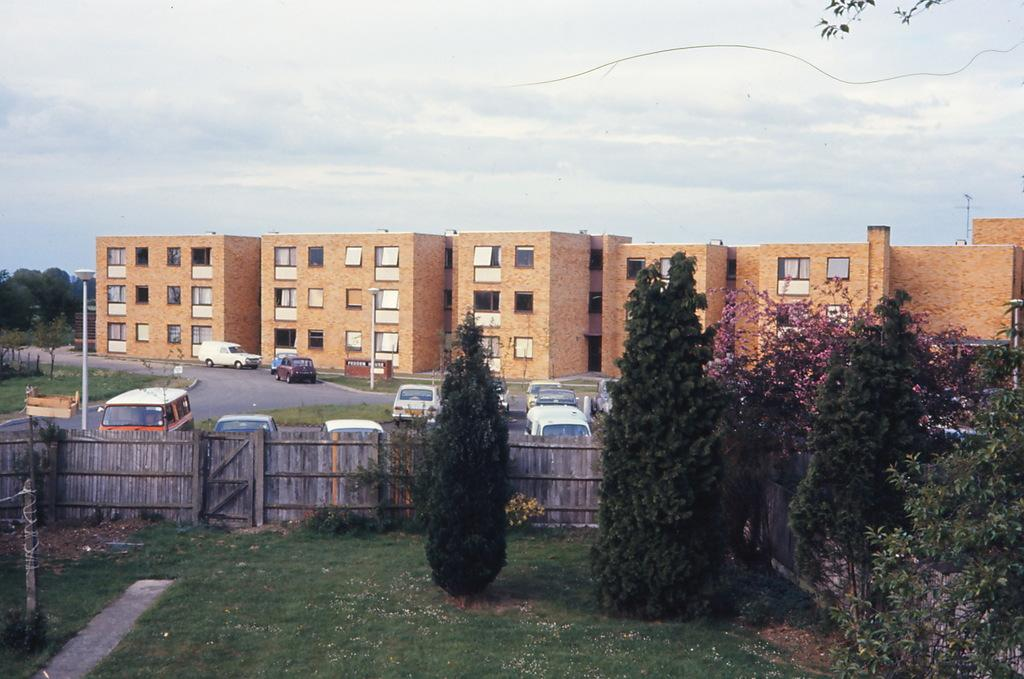What type of structures can be seen in the image? There are buildings in the image. What natural elements are present in the image? There are trees and plants in the image. What man-made objects can be seen in the image? There are cars in the image. Can you describe any other elements in the image? There are other unspecified things in the image. Are there any fairies weaving yarn in the image? There is no mention of fairies or yarn in the image, so we cannot confirm their presence. 